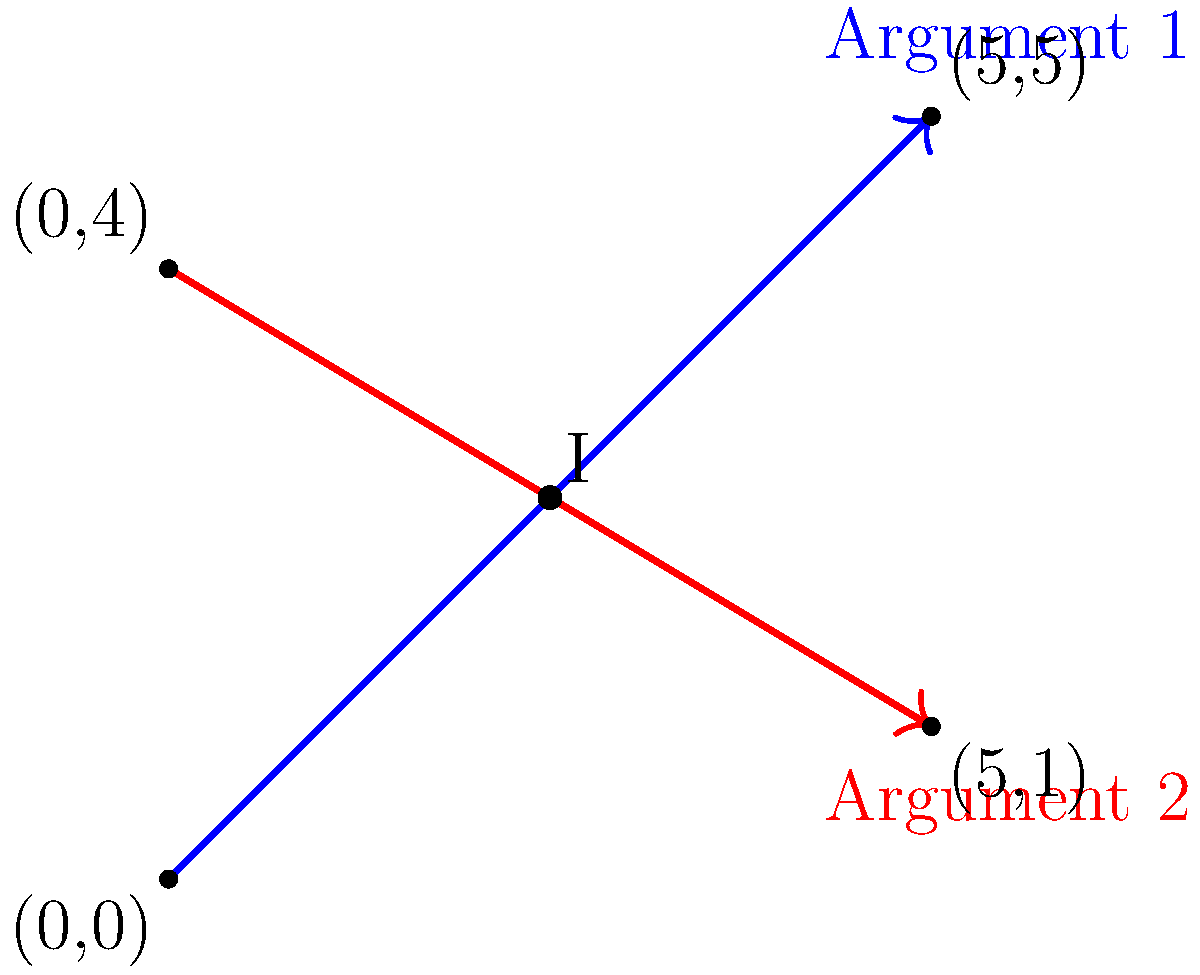In a landmark civil rights case, two conflicting arguments are represented by lines on a coordinate plane. Argument 1 is represented by the line passing through points (0,0) and (5,5), while Argument 2 is represented by the line passing through points (0,4) and (5,1). At what point do these arguments intersect, potentially representing a compromise or critical issue in the case? To find the intersection point of the two lines, we need to follow these steps:

1. Find the equations of both lines:

   For Argument 1 (blue line):
   Slope $m_1 = \frac{5-0}{5-0} = 1$
   Equation: $y = x$

   For Argument 2 (red line):
   Slope $m_2 = \frac{1-4}{5-0} = -\frac{3}{5}$
   Equation: $y = -\frac{3}{5}x + 4$

2. Set the equations equal to each other to find the intersection point:
   $x = -\frac{3}{5}x + 4$

3. Solve for x:
   $\frac{8}{5}x = 4$
   $x = \frac{20}{8} = \frac{5}{2} = 2.5$

4. Substitute this x-value into either equation to find y:
   $y = 2.5$

5. Therefore, the intersection point is (2.5, 2.5).

This point represents where the two arguments converge, potentially indicating a critical issue or possible compromise in the civil rights case.
Answer: (2.5, 2.5) 